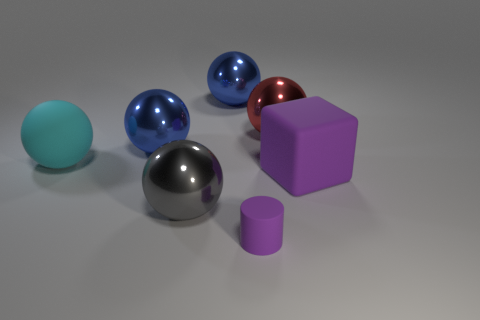Is the number of rubber blocks that are in front of the large red shiny object greater than the number of small red rubber cubes?
Your answer should be compact. Yes. There is a matte thing that is both on the left side of the red metal ball and on the right side of the large cyan matte object; how big is it?
Provide a short and direct response. Small. There is a red object that is the same shape as the cyan thing; what is its material?
Make the answer very short. Metal. Does the sphere in front of the matte block have the same size as the purple cube?
Ensure brevity in your answer.  Yes. What color is the rubber object that is to the right of the gray sphere and behind the small purple cylinder?
Ensure brevity in your answer.  Purple. There is a big blue metallic thing right of the large gray sphere; what number of big metallic objects are on the left side of it?
Keep it short and to the point. 2. Does the large red thing have the same shape as the big gray metallic object?
Offer a terse response. Yes. Is there anything else that is the same color as the cylinder?
Your answer should be very brief. Yes. There is a large gray shiny object; is its shape the same as the purple object that is right of the red ball?
Provide a succinct answer. No. What is the color of the large matte object left of the cube that is behind the big metal ball that is in front of the large cyan sphere?
Make the answer very short. Cyan. 